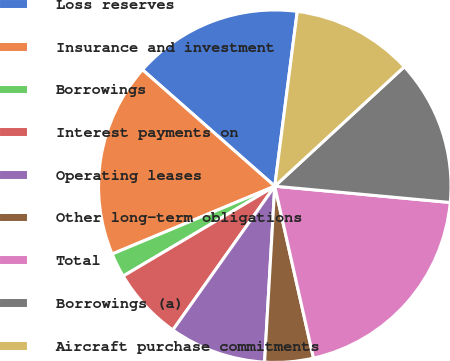Convert chart. <chart><loc_0><loc_0><loc_500><loc_500><pie_chart><fcel>Loss reserves<fcel>Insurance and investment<fcel>Borrowings<fcel>Interest payments on<fcel>Operating leases<fcel>Other long-term obligations<fcel>Total<fcel>Borrowings (a)<fcel>Aircraft purchase commitments<nl><fcel>15.55%<fcel>17.78%<fcel>2.23%<fcel>6.67%<fcel>8.89%<fcel>4.45%<fcel>20.0%<fcel>13.33%<fcel>11.11%<nl></chart> 